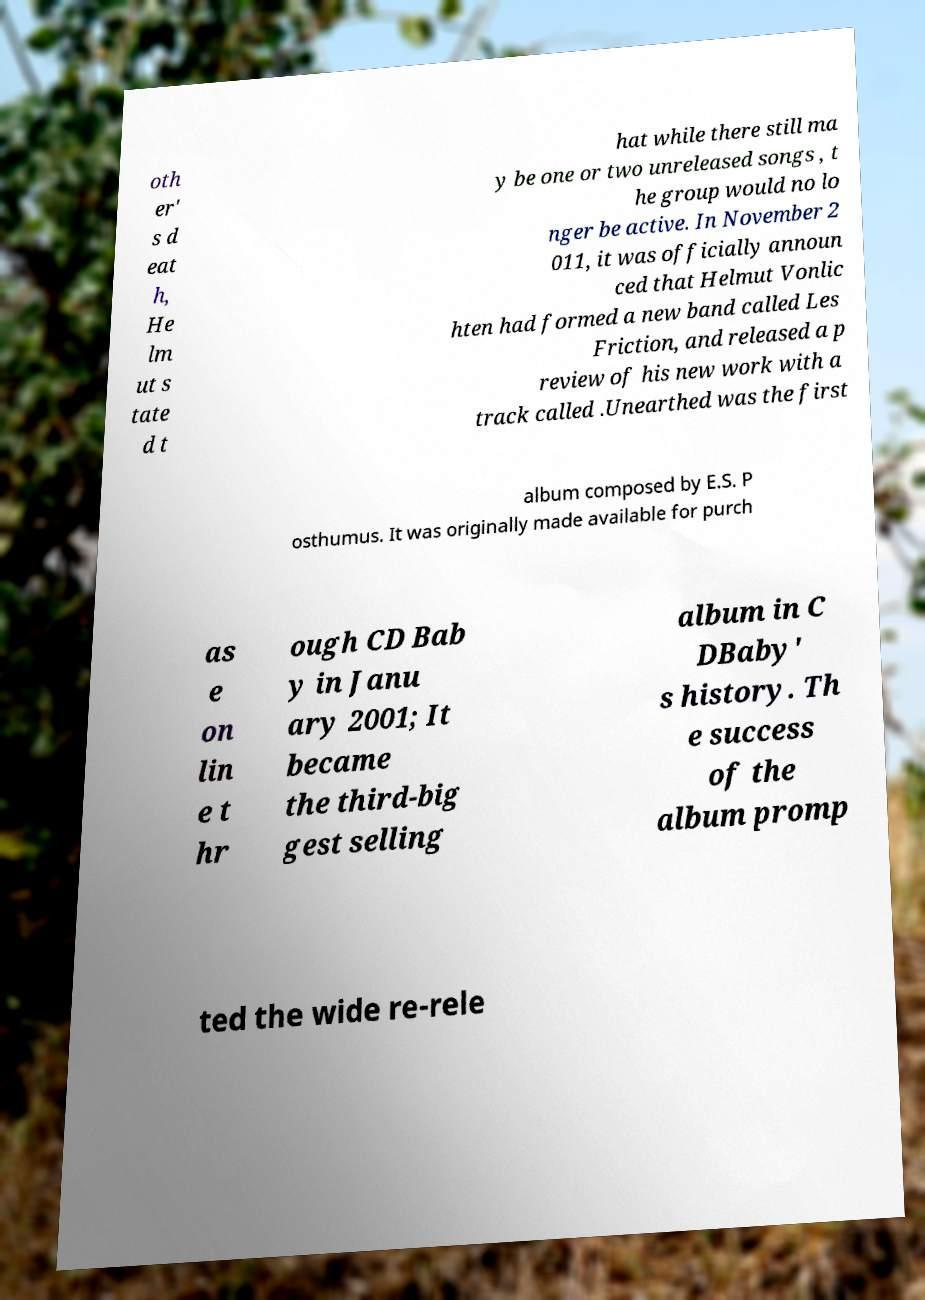Please read and relay the text visible in this image. What does it say? oth er' s d eat h, He lm ut s tate d t hat while there still ma y be one or two unreleased songs , t he group would no lo nger be active. In November 2 011, it was officially announ ced that Helmut Vonlic hten had formed a new band called Les Friction, and released a p review of his new work with a track called .Unearthed was the first album composed by E.S. P osthumus. It was originally made available for purch as e on lin e t hr ough CD Bab y in Janu ary 2001; It became the third-big gest selling album in C DBaby' s history. Th e success of the album promp ted the wide re-rele 